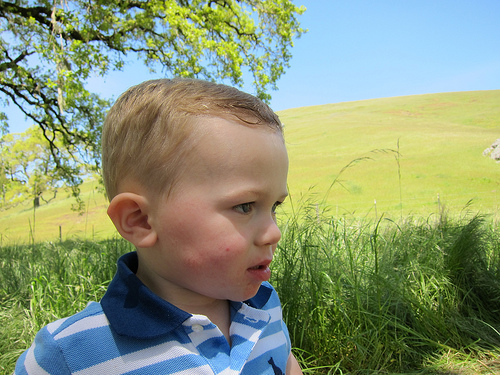<image>
Is the baby behind the grass? No. The baby is not behind the grass. From this viewpoint, the baby appears to be positioned elsewhere in the scene. 